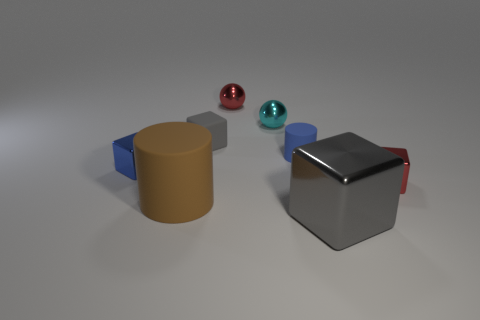Subtract all green blocks. Subtract all purple cylinders. How many blocks are left? 4 Add 1 tiny blue things. How many objects exist? 9 Subtract all spheres. How many objects are left? 6 Subtract all big blue metallic cylinders. Subtract all cylinders. How many objects are left? 6 Add 2 blue cubes. How many blue cubes are left? 3 Add 8 tiny blue cylinders. How many tiny blue cylinders exist? 9 Subtract 0 cyan cylinders. How many objects are left? 8 